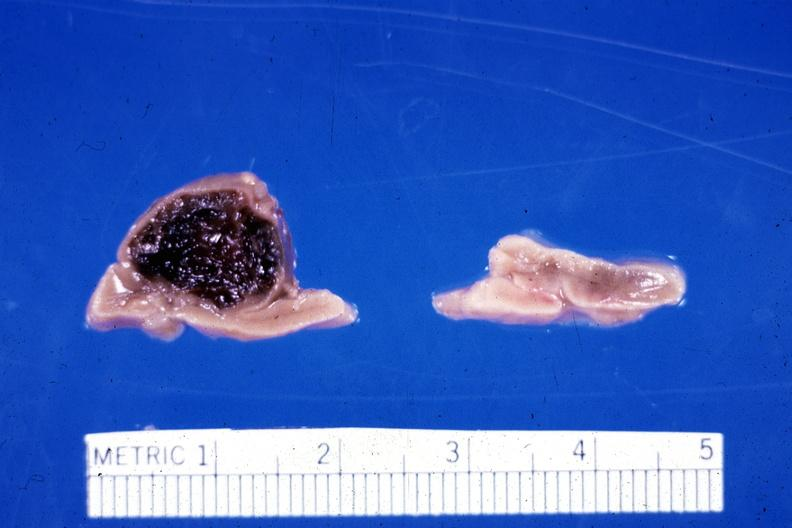s endocrine present?
Answer the question using a single word or phrase. Yes 